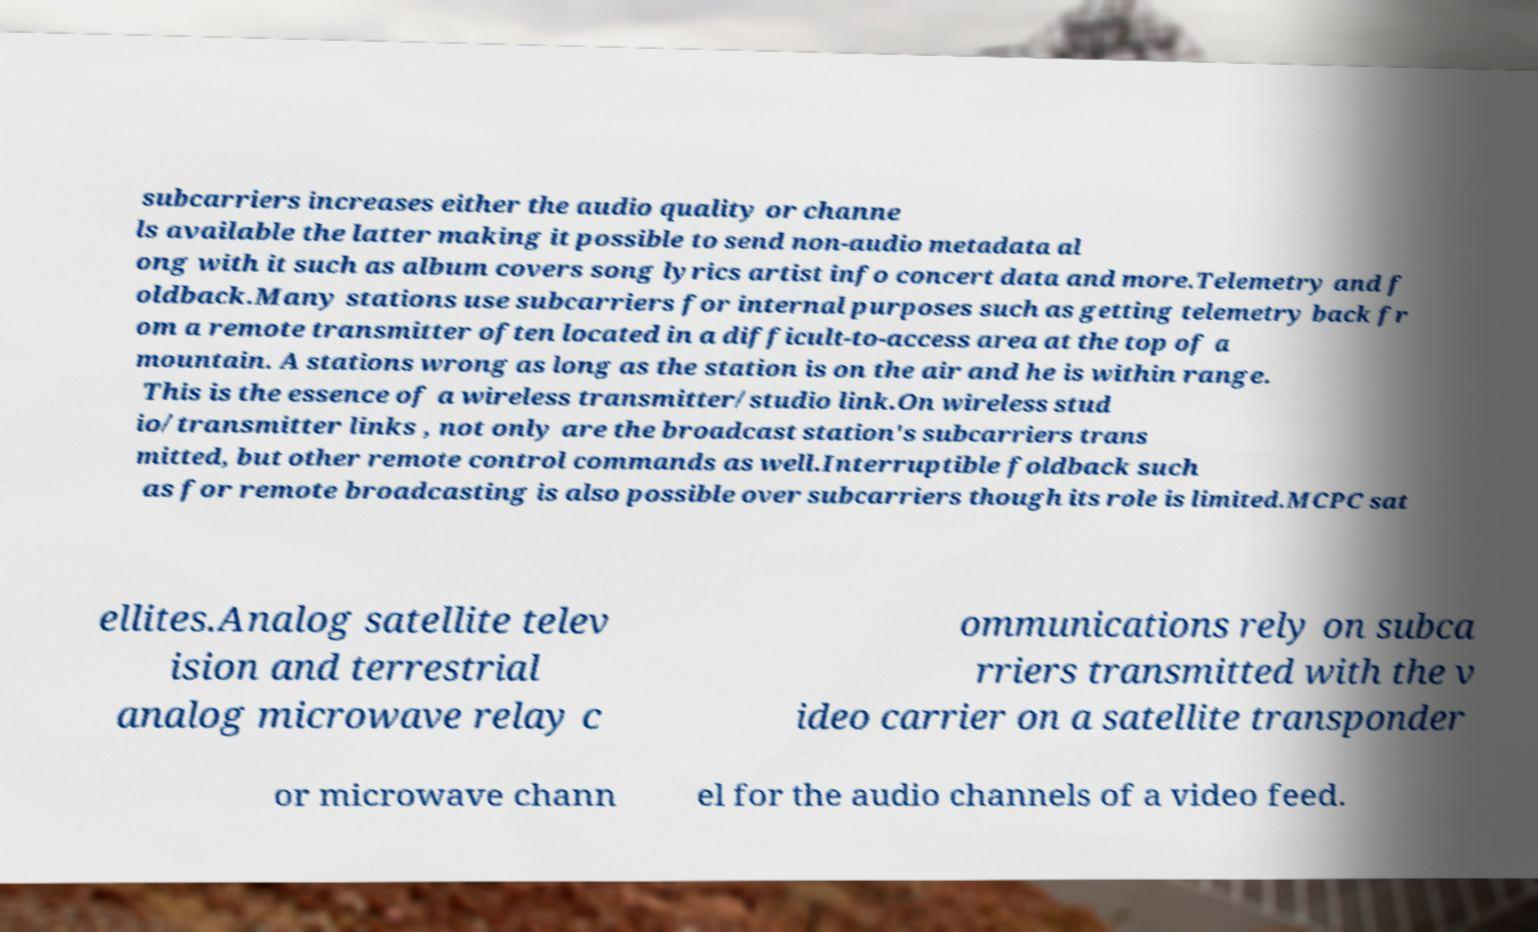Can you accurately transcribe the text from the provided image for me? subcarriers increases either the audio quality or channe ls available the latter making it possible to send non-audio metadata al ong with it such as album covers song lyrics artist info concert data and more.Telemetry and f oldback.Many stations use subcarriers for internal purposes such as getting telemetry back fr om a remote transmitter often located in a difficult-to-access area at the top of a mountain. A stations wrong as long as the station is on the air and he is within range. This is the essence of a wireless transmitter/studio link.On wireless stud io/transmitter links , not only are the broadcast station's subcarriers trans mitted, but other remote control commands as well.Interruptible foldback such as for remote broadcasting is also possible over subcarriers though its role is limited.MCPC sat ellites.Analog satellite telev ision and terrestrial analog microwave relay c ommunications rely on subca rriers transmitted with the v ideo carrier on a satellite transponder or microwave chann el for the audio channels of a video feed. 